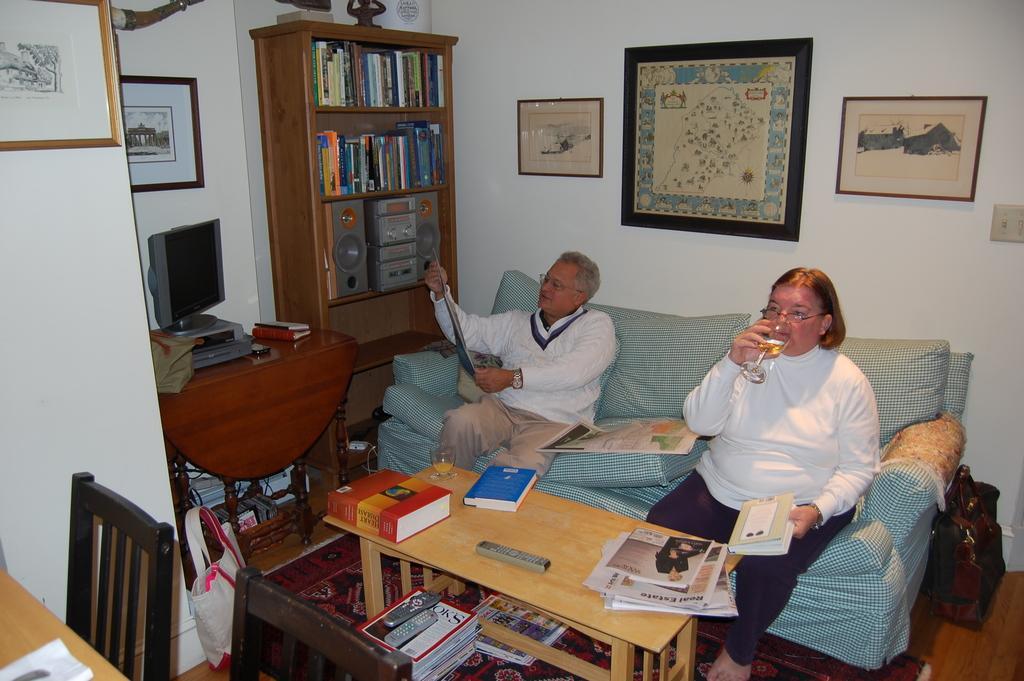Please provide a concise description of this image. The women in the right is sitting and holding a book in one of her hand and drinking a glass of wine and there is other person sitting beside her and there is a table in front of them which has papers and books on it and there are some other books under it and there is a bookshelf and some paintings in the background. 